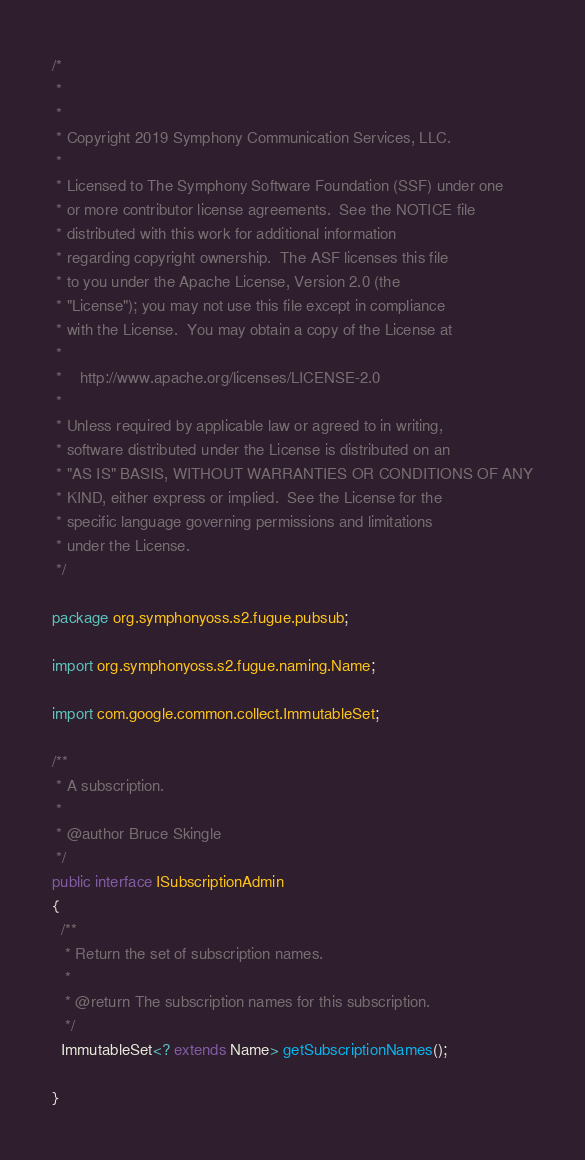<code> <loc_0><loc_0><loc_500><loc_500><_Java_>/*
 *
 *
 * Copyright 2019 Symphony Communication Services, LLC.
 *
 * Licensed to The Symphony Software Foundation (SSF) under one
 * or more contributor license agreements.  See the NOTICE file
 * distributed with this work for additional information
 * regarding copyright ownership.  The ASF licenses this file
 * to you under the Apache License, Version 2.0 (the
 * "License"); you may not use this file except in compliance
 * with the License.  You may obtain a copy of the License at
 *
 *    http://www.apache.org/licenses/LICENSE-2.0
 *
 * Unless required by applicable law or agreed to in writing,
 * software distributed under the License is distributed on an
 * "AS IS" BASIS, WITHOUT WARRANTIES OR CONDITIONS OF ANY
 * KIND, either express or implied.  See the License for the
 * specific language governing permissions and limitations
 * under the License.
 */

package org.symphonyoss.s2.fugue.pubsub;

import org.symphonyoss.s2.fugue.naming.Name;

import com.google.common.collect.ImmutableSet;

/**
 * A subscription.
 * 
 * @author Bruce Skingle
 */
public interface ISubscriptionAdmin
{
  /**
   * Return the set of subscription names.
   * 
   * @return The subscription names for this subscription.
   */
  ImmutableSet<? extends Name> getSubscriptionNames();

}
</code> 